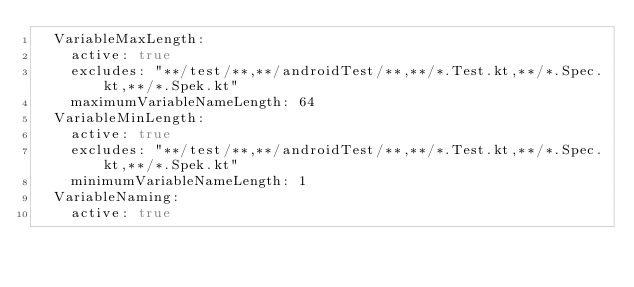<code> <loc_0><loc_0><loc_500><loc_500><_YAML_>  VariableMaxLength:
    active: true
    excludes: "**/test/**,**/androidTest/**,**/*.Test.kt,**/*.Spec.kt,**/*.Spek.kt"
    maximumVariableNameLength: 64
  VariableMinLength:
    active: true
    excludes: "**/test/**,**/androidTest/**,**/*.Test.kt,**/*.Spec.kt,**/*.Spek.kt"
    minimumVariableNameLength: 1
  VariableNaming:
    active: true</code> 